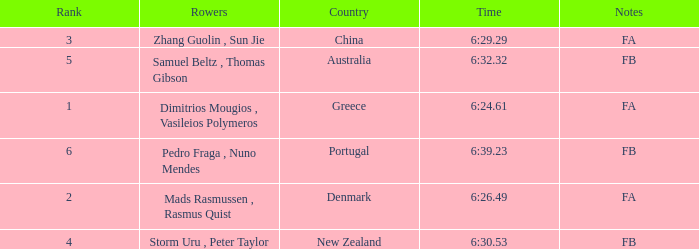What country has a rank smaller than 6, a time of 6:32.32 and notes of FB? Australia. 